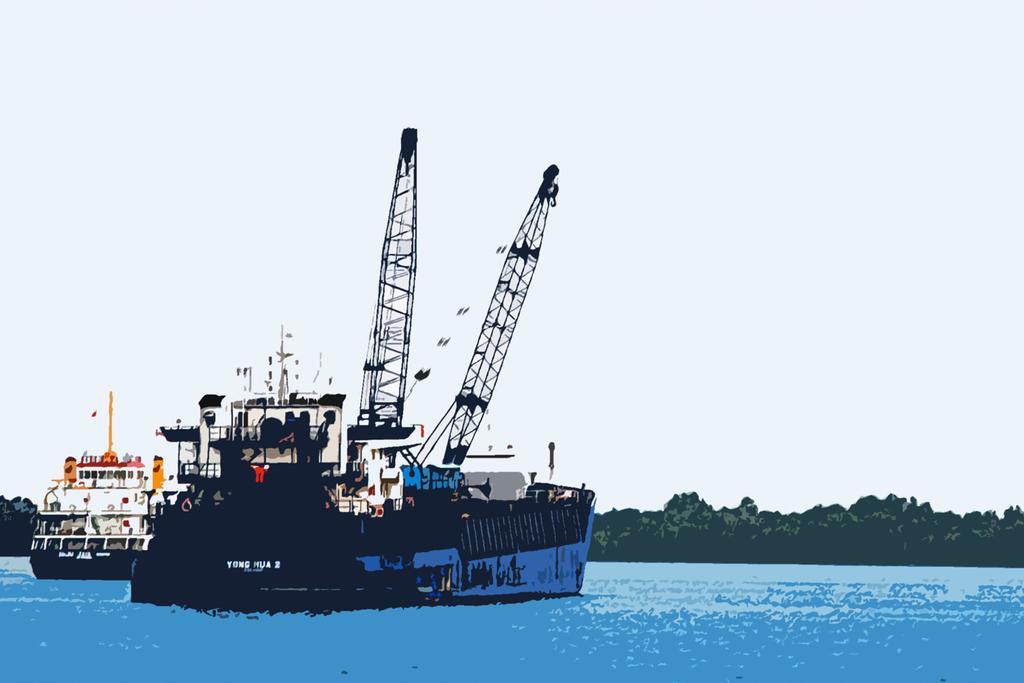In one or two sentences, can you explain what this image depicts? This image is a painting. In this painting we can see ships. At the bottom there is water. In the background there is a hill and sky. 